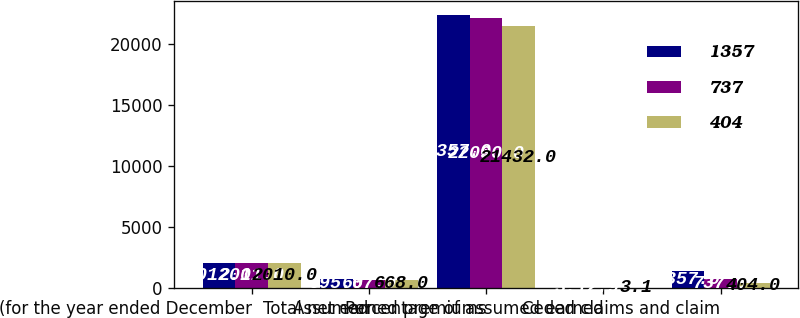<chart> <loc_0><loc_0><loc_500><loc_500><stacked_bar_chart><ecel><fcel>(for the year ended December<fcel>Assumed<fcel>Total net earned premiums<fcel>Percentage of assumed earned<fcel>Ceded claims and claim<nl><fcel>1357<fcel>2012<fcel>695<fcel>22357<fcel>3.1<fcel>1357<nl><fcel>737<fcel>2011<fcel>667<fcel>22090<fcel>2.9<fcel>737<nl><fcel>404<fcel>2010<fcel>668<fcel>21432<fcel>3.1<fcel>404<nl></chart> 